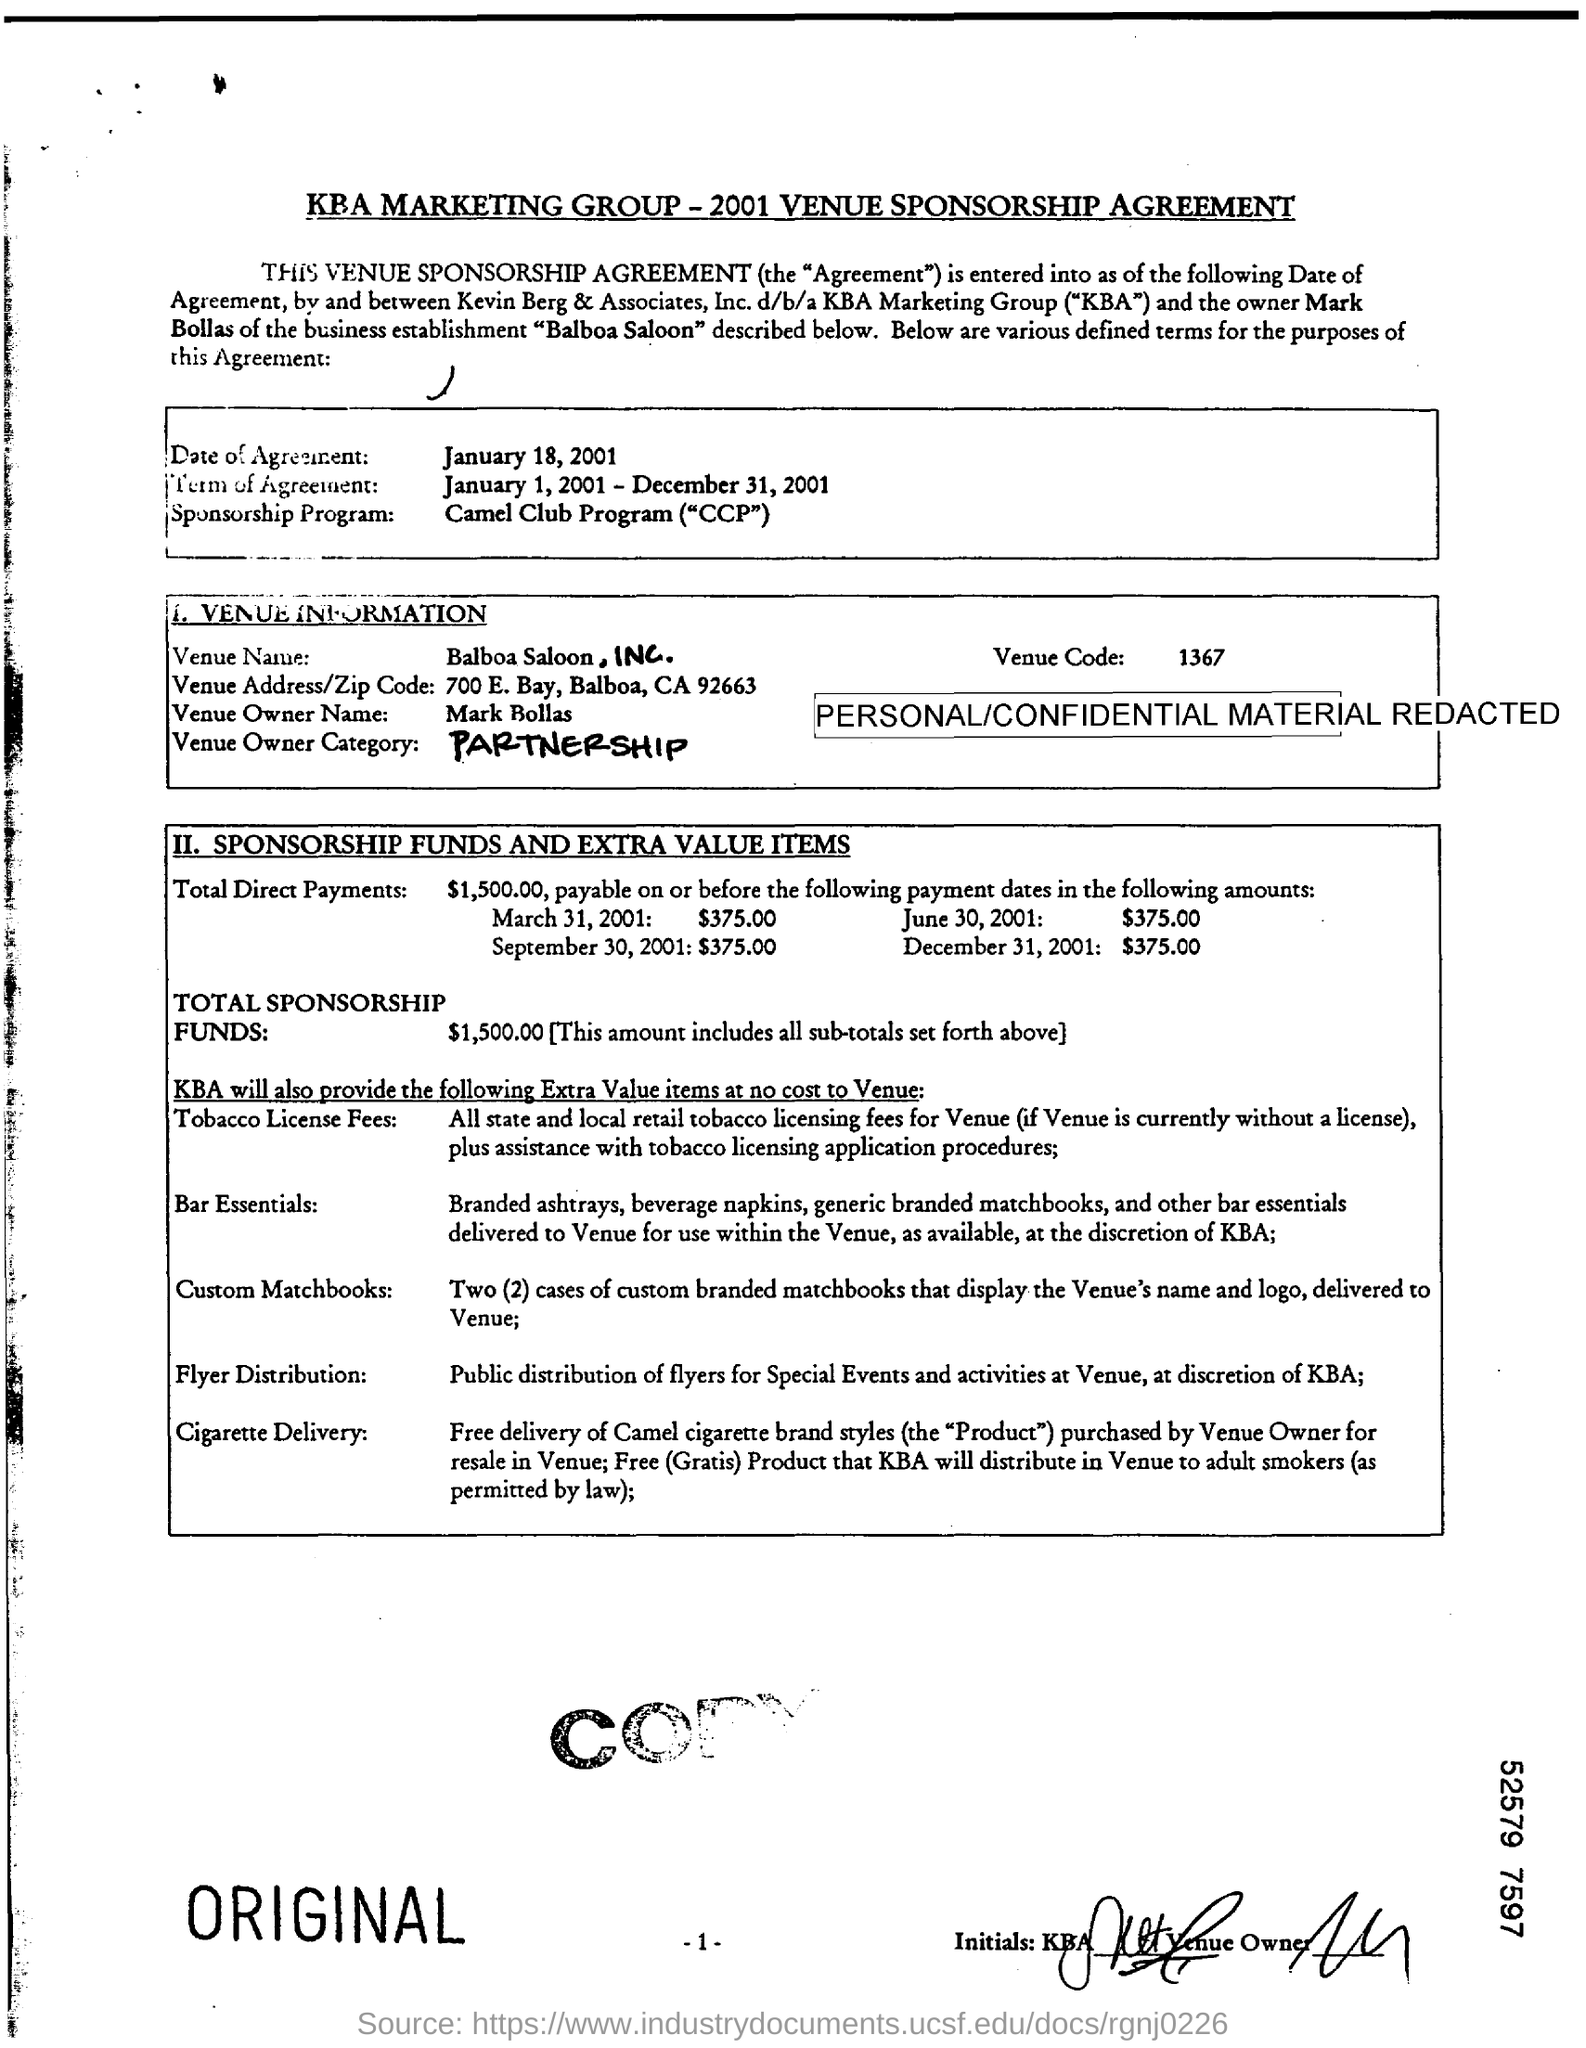When is the Date of Agreement?
Offer a terse response. January 18, 2001. What is the Term of Agreement?
Keep it short and to the point. January 1, 2001 - December 31, 2001. What is the Venue Name?
Provide a short and direct response. Balboa Saloon, INC. 